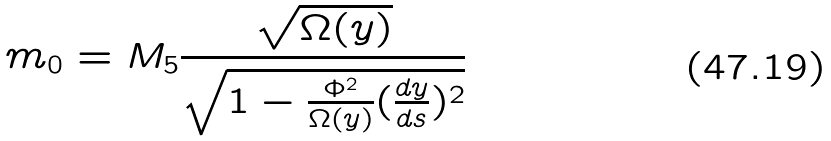<formula> <loc_0><loc_0><loc_500><loc_500>m _ { 0 } = M _ { 5 } \frac { \sqrt { \Omega ( y ) } } { \sqrt { 1 - \frac { \Phi ^ { 2 } } { \Omega ( y ) } ( \frac { d y } { d s } ) ^ { 2 } } }</formula> 